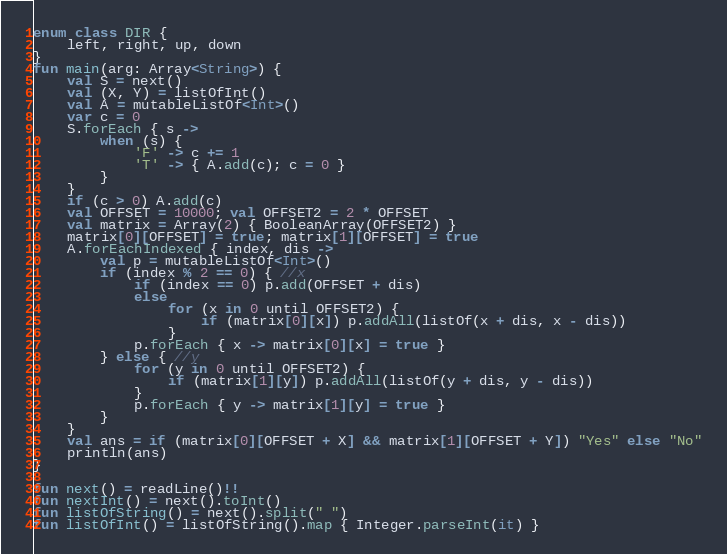<code> <loc_0><loc_0><loc_500><loc_500><_Kotlin_>enum class DIR {
    left, right, up, down
}
fun main(arg: Array<String>) {
    val S = next()
    val (X, Y) = listOfInt()
    val A = mutableListOf<Int>()
    var c = 0
    S.forEach { s ->
        when (s) {
            'F' -> c += 1
            'T' -> { A.add(c); c = 0 }
        }
    }
    if (c > 0) A.add(c)
    val OFFSET = 10000; val OFFSET2 = 2 * OFFSET
    val matrix = Array(2) { BooleanArray(OFFSET2) }
    matrix[0][OFFSET] = true; matrix[1][OFFSET] = true
    A.forEachIndexed { index, dis ->
        val p = mutableListOf<Int>()
        if (index % 2 == 0) { //x
            if (index == 0) p.add(OFFSET + dis)
            else
                for (x in 0 until OFFSET2) {
                    if (matrix[0][x]) p.addAll(listOf(x + dis, x - dis))
                }
            p.forEach { x -> matrix[0][x] = true }
        } else { //y
            for (y in 0 until OFFSET2) {
                if (matrix[1][y]) p.addAll(listOf(y + dis, y - dis))
            }
            p.forEach { y -> matrix[1][y] = true }
        }
    }
    val ans = if (matrix[0][OFFSET + X] && matrix[1][OFFSET + Y]) "Yes" else "No"
    println(ans)
}

fun next() = readLine()!!
fun nextInt() = next().toInt()
fun listOfString() = next().split(" ")
fun listOfInt() = listOfString().map { Integer.parseInt(it) }
</code> 